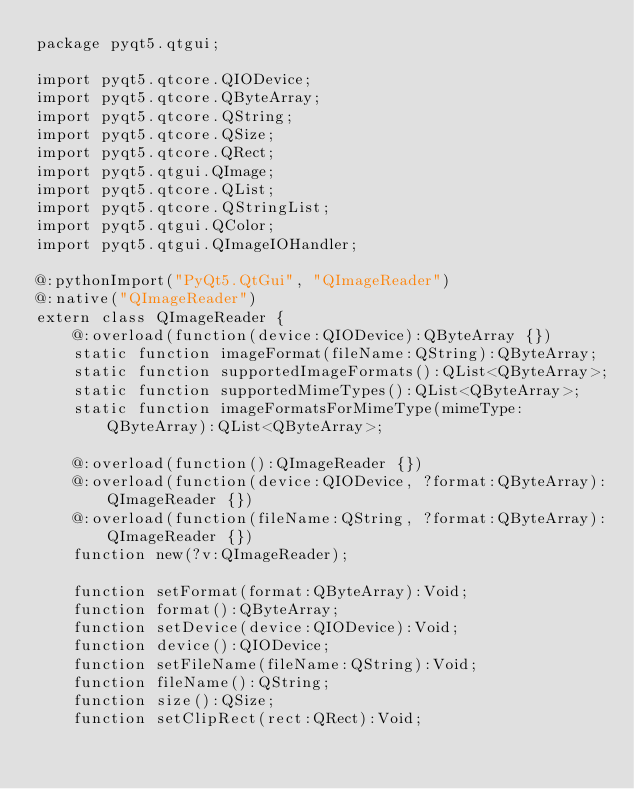<code> <loc_0><loc_0><loc_500><loc_500><_Haxe_>package pyqt5.qtgui;

import pyqt5.qtcore.QIODevice;
import pyqt5.qtcore.QByteArray;
import pyqt5.qtcore.QString;
import pyqt5.qtcore.QSize;
import pyqt5.qtcore.QRect;
import pyqt5.qtgui.QImage;
import pyqt5.qtcore.QList;
import pyqt5.qtcore.QStringList;
import pyqt5.qtgui.QColor;
import pyqt5.qtgui.QImageIOHandler;

@:pythonImport("PyQt5.QtGui", "QImageReader")
@:native("QImageReader")
extern class QImageReader {
	@:overload(function(device:QIODevice):QByteArray {})
	static function imageFormat(fileName:QString):QByteArray;
	static function supportedImageFormats():QList<QByteArray>;
	static function supportedMimeTypes():QList<QByteArray>;
	static function imageFormatsForMimeType(mimeType:QByteArray):QList<QByteArray>;

	@:overload(function():QImageReader {})
	@:overload(function(device:QIODevice, ?format:QByteArray):QImageReader {})
	@:overload(function(fileName:QString, ?format:QByteArray):QImageReader {})
	function new(?v:QImageReader);

	function setFormat(format:QByteArray):Void;
	function format():QByteArray;
	function setDevice(device:QIODevice):Void;
	function device():QIODevice;
	function setFileName(fileName:QString):Void;
	function fileName():QString;
	function size():QSize;
	function setClipRect(rect:QRect):Void;</code> 